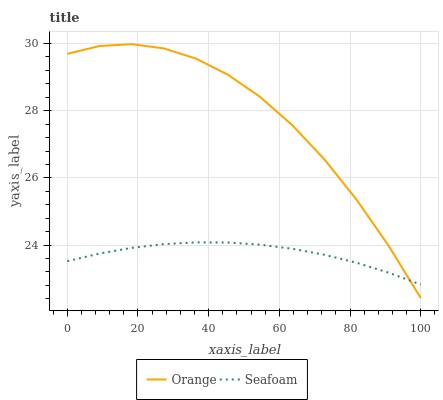Does Seafoam have the minimum area under the curve?
Answer yes or no. Yes. Does Orange have the maximum area under the curve?
Answer yes or no. Yes. Does Seafoam have the maximum area under the curve?
Answer yes or no. No. Is Seafoam the smoothest?
Answer yes or no. Yes. Is Orange the roughest?
Answer yes or no. Yes. Is Seafoam the roughest?
Answer yes or no. No. Does Orange have the lowest value?
Answer yes or no. Yes. Does Seafoam have the lowest value?
Answer yes or no. No. Does Orange have the highest value?
Answer yes or no. Yes. Does Seafoam have the highest value?
Answer yes or no. No. Does Orange intersect Seafoam?
Answer yes or no. Yes. Is Orange less than Seafoam?
Answer yes or no. No. Is Orange greater than Seafoam?
Answer yes or no. No. 